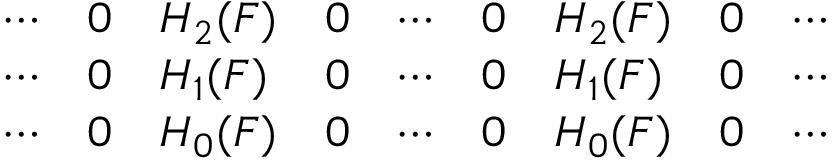<formula> <loc_0><loc_0><loc_500><loc_500>\begin{array} { l l l l l l l l l } { \cdots } & { 0 } & { H _ { 2 } ( F ) } & { 0 } & { \cdots } & { 0 } & { H _ { 2 } ( F ) } & { 0 } & { \cdots } \\ { \cdots } & { 0 } & { H _ { 1 } ( F ) } & { 0 } & { \cdots } & { 0 } & { H _ { 1 } ( F ) } & { 0 } & { \cdots } \\ { \cdots } & { 0 } & { H _ { 0 } ( F ) } & { 0 } & { \cdots } & { 0 } & { H _ { 0 } ( F ) } & { 0 } & { \cdots } \end{array}</formula> 